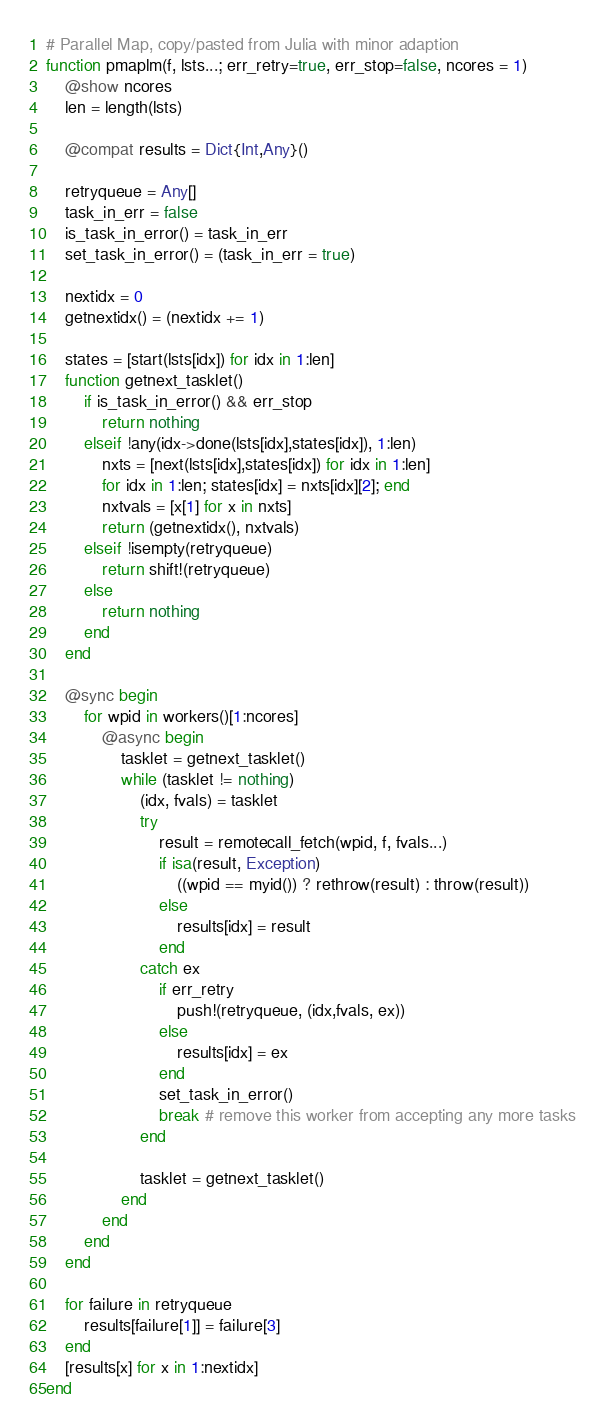<code> <loc_0><loc_0><loc_500><loc_500><_Julia_># Parallel Map, copy/pasted from Julia with minor adaption
function pmaplm(f, lsts...; err_retry=true, err_stop=false, ncores = 1)
    @show ncores
    len = length(lsts)

    @compat results = Dict{Int,Any}()

    retryqueue = Any[]
    task_in_err = false
    is_task_in_error() = task_in_err
    set_task_in_error() = (task_in_err = true)

    nextidx = 0
    getnextidx() = (nextidx += 1)

    states = [start(lsts[idx]) for idx in 1:len]
    function getnext_tasklet()
        if is_task_in_error() && err_stop
            return nothing
        elseif !any(idx->done(lsts[idx],states[idx]), 1:len)
            nxts = [next(lsts[idx],states[idx]) for idx in 1:len]
            for idx in 1:len; states[idx] = nxts[idx][2]; end
            nxtvals = [x[1] for x in nxts]
            return (getnextidx(), nxtvals)
        elseif !isempty(retryqueue)
            return shift!(retryqueue)
        else
            return nothing
        end
    end

    @sync begin
        for wpid in workers()[1:ncores]
            @async begin
                tasklet = getnext_tasklet()
                while (tasklet != nothing)
                    (idx, fvals) = tasklet
                    try
                        result = remotecall_fetch(wpid, f, fvals...)
                        if isa(result, Exception)
                            ((wpid == myid()) ? rethrow(result) : throw(result))
                        else
                            results[idx] = result
                        end
                    catch ex
                        if err_retry
                            push!(retryqueue, (idx,fvals, ex))
                        else
                            results[idx] = ex
                        end
                        set_task_in_error()
                        break # remove this worker from accepting any more tasks
                    end

                    tasklet = getnext_tasklet()
                end
            end
        end
    end

    for failure in retryqueue
        results[failure[1]] = failure[3]
    end
    [results[x] for x in 1:nextidx]
end
</code> 